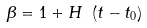<formula> <loc_0><loc_0><loc_500><loc_500>\beta = 1 + H \ ( t - t _ { 0 } )</formula> 